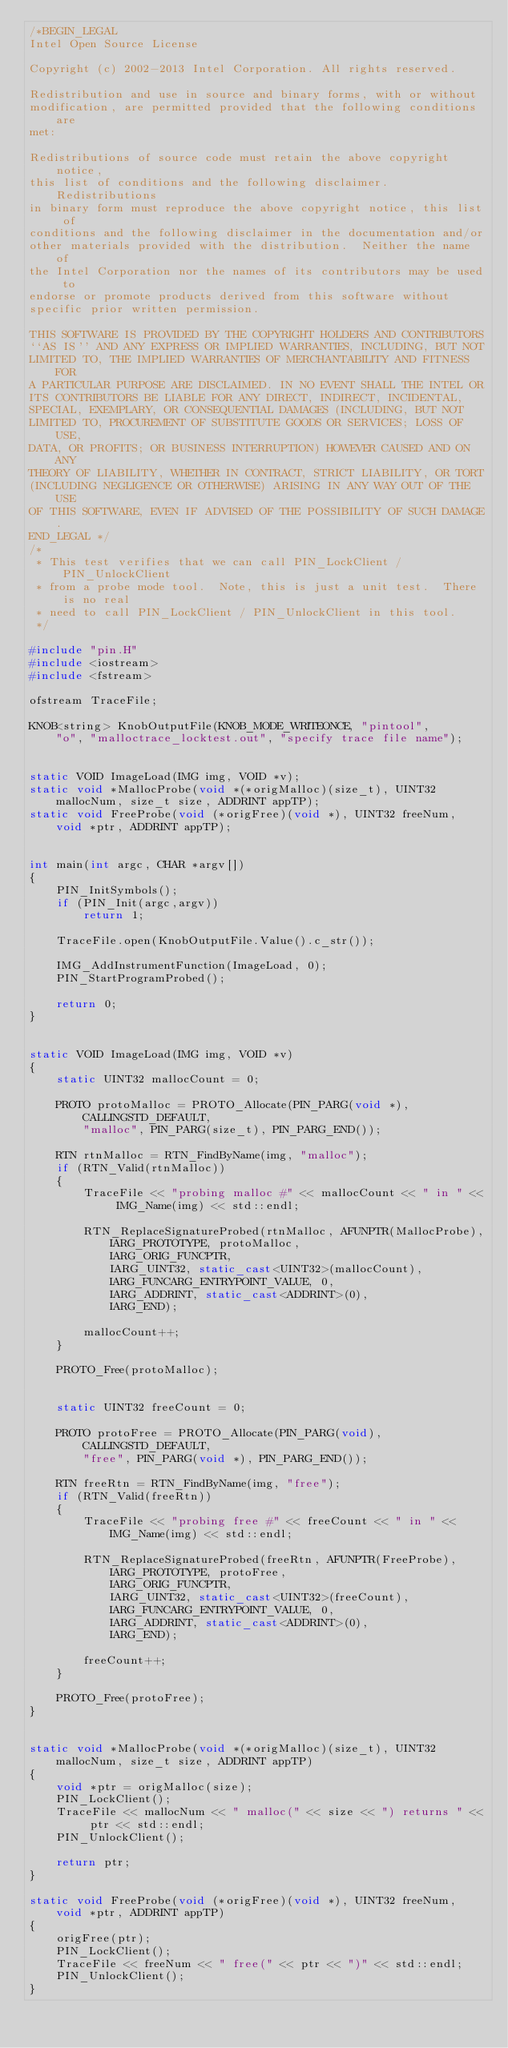<code> <loc_0><loc_0><loc_500><loc_500><_C++_>/*BEGIN_LEGAL 
Intel Open Source License 

Copyright (c) 2002-2013 Intel Corporation. All rights reserved.
 
Redistribution and use in source and binary forms, with or without
modification, are permitted provided that the following conditions are
met:

Redistributions of source code must retain the above copyright notice,
this list of conditions and the following disclaimer.  Redistributions
in binary form must reproduce the above copyright notice, this list of
conditions and the following disclaimer in the documentation and/or
other materials provided with the distribution.  Neither the name of
the Intel Corporation nor the names of its contributors may be used to
endorse or promote products derived from this software without
specific prior written permission.
 
THIS SOFTWARE IS PROVIDED BY THE COPYRIGHT HOLDERS AND CONTRIBUTORS
``AS IS'' AND ANY EXPRESS OR IMPLIED WARRANTIES, INCLUDING, BUT NOT
LIMITED TO, THE IMPLIED WARRANTIES OF MERCHANTABILITY AND FITNESS FOR
A PARTICULAR PURPOSE ARE DISCLAIMED. IN NO EVENT SHALL THE INTEL OR
ITS CONTRIBUTORS BE LIABLE FOR ANY DIRECT, INDIRECT, INCIDENTAL,
SPECIAL, EXEMPLARY, OR CONSEQUENTIAL DAMAGES (INCLUDING, BUT NOT
LIMITED TO, PROCUREMENT OF SUBSTITUTE GOODS OR SERVICES; LOSS OF USE,
DATA, OR PROFITS; OR BUSINESS INTERRUPTION) HOWEVER CAUSED AND ON ANY
THEORY OF LIABILITY, WHETHER IN CONTRACT, STRICT LIABILITY, OR TORT
(INCLUDING NEGLIGENCE OR OTHERWISE) ARISING IN ANY WAY OUT OF THE USE
OF THIS SOFTWARE, EVEN IF ADVISED OF THE POSSIBILITY OF SUCH DAMAGE.
END_LEGAL */
/*
 * This test verifies that we can call PIN_LockClient / PIN_UnlockClient
 * from a probe mode tool.  Note, this is just a unit test.  There is no real
 * need to call PIN_LockClient / PIN_UnlockClient in this tool.
 */

#include "pin.H"
#include <iostream>
#include <fstream>

ofstream TraceFile;

KNOB<string> KnobOutputFile(KNOB_MODE_WRITEONCE, "pintool",
    "o", "malloctrace_locktest.out", "specify trace file name");


static VOID ImageLoad(IMG img, VOID *v);
static void *MallocProbe(void *(*origMalloc)(size_t), UINT32 mallocNum, size_t size, ADDRINT appTP);
static void FreeProbe(void (*origFree)(void *), UINT32 freeNum, void *ptr, ADDRINT appTP);


int main(int argc, CHAR *argv[])
{
    PIN_InitSymbols();
    if (PIN_Init(argc,argv))
        return 1;

    TraceFile.open(KnobOutputFile.Value().c_str());

    IMG_AddInstrumentFunction(ImageLoad, 0);
    PIN_StartProgramProbed();

    return 0;
}


static VOID ImageLoad(IMG img, VOID *v)
{
    static UINT32 mallocCount = 0;

    PROTO protoMalloc = PROTO_Allocate(PIN_PARG(void *), CALLINGSTD_DEFAULT,
        "malloc", PIN_PARG(size_t), PIN_PARG_END());

    RTN rtnMalloc = RTN_FindByName(img, "malloc");
    if (RTN_Valid(rtnMalloc))
    {
        TraceFile << "probing malloc #" << mallocCount << " in " << IMG_Name(img) << std::endl;

        RTN_ReplaceSignatureProbed(rtnMalloc, AFUNPTR(MallocProbe),
            IARG_PROTOTYPE, protoMalloc,
            IARG_ORIG_FUNCPTR,
            IARG_UINT32, static_cast<UINT32>(mallocCount),
            IARG_FUNCARG_ENTRYPOINT_VALUE, 0,
            IARG_ADDRINT, static_cast<ADDRINT>(0),
            IARG_END);

        mallocCount++;
    }

    PROTO_Free(protoMalloc);


    static UINT32 freeCount = 0;

    PROTO protoFree = PROTO_Allocate(PIN_PARG(void), CALLINGSTD_DEFAULT,
        "free", PIN_PARG(void *), PIN_PARG_END());

    RTN freeRtn = RTN_FindByName(img, "free");
    if (RTN_Valid(freeRtn))
    {
        TraceFile << "probing free #" << freeCount << " in " << IMG_Name(img) << std::endl;

        RTN_ReplaceSignatureProbed(freeRtn, AFUNPTR(FreeProbe),
            IARG_PROTOTYPE, protoFree,
            IARG_ORIG_FUNCPTR,
            IARG_UINT32, static_cast<UINT32>(freeCount),
            IARG_FUNCARG_ENTRYPOINT_VALUE, 0,
            IARG_ADDRINT, static_cast<ADDRINT>(0),
            IARG_END);

        freeCount++;
    }

    PROTO_Free(protoFree);
}


static void *MallocProbe(void *(*origMalloc)(size_t), UINT32 mallocNum, size_t size, ADDRINT appTP)
{
    void *ptr = origMalloc(size);
    PIN_LockClient();
    TraceFile << mallocNum << " malloc(" << size << ") returns " << ptr << std::endl;
    PIN_UnlockClient();

    return ptr;
}

static void FreeProbe(void (*origFree)(void *), UINT32 freeNum, void *ptr, ADDRINT appTP)
{
    origFree(ptr);
    PIN_LockClient();
    TraceFile << freeNum << " free(" << ptr << ")" << std::endl;
    PIN_UnlockClient();
}
</code> 